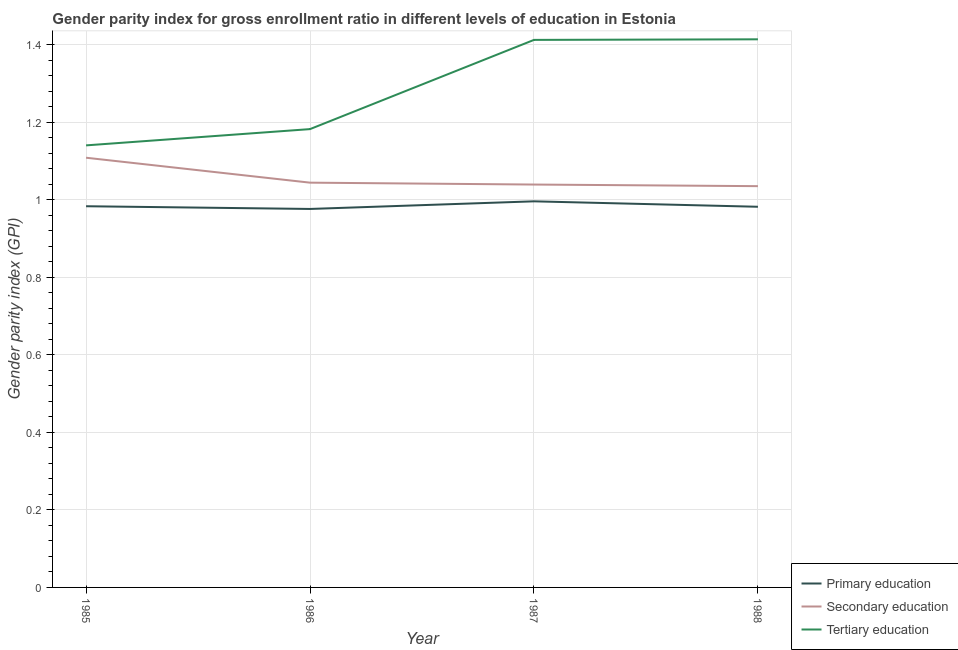What is the gender parity index in secondary education in 1987?
Provide a succinct answer. 1.04. Across all years, what is the maximum gender parity index in tertiary education?
Give a very brief answer. 1.41. Across all years, what is the minimum gender parity index in tertiary education?
Make the answer very short. 1.14. What is the total gender parity index in secondary education in the graph?
Keep it short and to the point. 4.23. What is the difference between the gender parity index in primary education in 1986 and that in 1988?
Your answer should be compact. -0.01. What is the difference between the gender parity index in secondary education in 1985 and the gender parity index in tertiary education in 1988?
Provide a short and direct response. -0.31. What is the average gender parity index in secondary education per year?
Your answer should be compact. 1.06. In the year 1986, what is the difference between the gender parity index in tertiary education and gender parity index in secondary education?
Keep it short and to the point. 0.14. In how many years, is the gender parity index in primary education greater than 0.52?
Your answer should be very brief. 4. What is the ratio of the gender parity index in secondary education in 1985 to that in 1987?
Provide a succinct answer. 1.07. Is the gender parity index in tertiary education in 1986 less than that in 1987?
Ensure brevity in your answer.  Yes. What is the difference between the highest and the second highest gender parity index in tertiary education?
Ensure brevity in your answer.  0. What is the difference between the highest and the lowest gender parity index in tertiary education?
Your answer should be very brief. 0.27. In how many years, is the gender parity index in secondary education greater than the average gender parity index in secondary education taken over all years?
Give a very brief answer. 1. Is it the case that in every year, the sum of the gender parity index in primary education and gender parity index in secondary education is greater than the gender parity index in tertiary education?
Provide a succinct answer. Yes. Is the gender parity index in secondary education strictly greater than the gender parity index in primary education over the years?
Ensure brevity in your answer.  Yes. What is the difference between two consecutive major ticks on the Y-axis?
Keep it short and to the point. 0.2. Are the values on the major ticks of Y-axis written in scientific E-notation?
Offer a terse response. No. What is the title of the graph?
Your answer should be compact. Gender parity index for gross enrollment ratio in different levels of education in Estonia. What is the label or title of the X-axis?
Offer a very short reply. Year. What is the label or title of the Y-axis?
Your answer should be compact. Gender parity index (GPI). What is the Gender parity index (GPI) in Primary education in 1985?
Provide a succinct answer. 0.98. What is the Gender parity index (GPI) of Secondary education in 1985?
Ensure brevity in your answer.  1.11. What is the Gender parity index (GPI) of Tertiary education in 1985?
Give a very brief answer. 1.14. What is the Gender parity index (GPI) in Primary education in 1986?
Give a very brief answer. 0.98. What is the Gender parity index (GPI) of Secondary education in 1986?
Offer a terse response. 1.04. What is the Gender parity index (GPI) of Tertiary education in 1986?
Keep it short and to the point. 1.18. What is the Gender parity index (GPI) in Primary education in 1987?
Give a very brief answer. 1. What is the Gender parity index (GPI) in Secondary education in 1987?
Ensure brevity in your answer.  1.04. What is the Gender parity index (GPI) in Tertiary education in 1987?
Offer a terse response. 1.41. What is the Gender parity index (GPI) of Primary education in 1988?
Provide a short and direct response. 0.98. What is the Gender parity index (GPI) in Secondary education in 1988?
Give a very brief answer. 1.04. What is the Gender parity index (GPI) in Tertiary education in 1988?
Ensure brevity in your answer.  1.41. Across all years, what is the maximum Gender parity index (GPI) in Primary education?
Offer a very short reply. 1. Across all years, what is the maximum Gender parity index (GPI) of Secondary education?
Your response must be concise. 1.11. Across all years, what is the maximum Gender parity index (GPI) in Tertiary education?
Give a very brief answer. 1.41. Across all years, what is the minimum Gender parity index (GPI) of Primary education?
Provide a short and direct response. 0.98. Across all years, what is the minimum Gender parity index (GPI) in Secondary education?
Provide a short and direct response. 1.04. Across all years, what is the minimum Gender parity index (GPI) in Tertiary education?
Keep it short and to the point. 1.14. What is the total Gender parity index (GPI) in Primary education in the graph?
Provide a short and direct response. 3.94. What is the total Gender parity index (GPI) in Secondary education in the graph?
Give a very brief answer. 4.23. What is the total Gender parity index (GPI) of Tertiary education in the graph?
Provide a short and direct response. 5.15. What is the difference between the Gender parity index (GPI) of Primary education in 1985 and that in 1986?
Provide a succinct answer. 0.01. What is the difference between the Gender parity index (GPI) of Secondary education in 1985 and that in 1986?
Make the answer very short. 0.06. What is the difference between the Gender parity index (GPI) of Tertiary education in 1985 and that in 1986?
Ensure brevity in your answer.  -0.04. What is the difference between the Gender parity index (GPI) of Primary education in 1985 and that in 1987?
Ensure brevity in your answer.  -0.01. What is the difference between the Gender parity index (GPI) in Secondary education in 1985 and that in 1987?
Your answer should be very brief. 0.07. What is the difference between the Gender parity index (GPI) in Tertiary education in 1985 and that in 1987?
Offer a terse response. -0.27. What is the difference between the Gender parity index (GPI) of Primary education in 1985 and that in 1988?
Provide a succinct answer. 0. What is the difference between the Gender parity index (GPI) of Secondary education in 1985 and that in 1988?
Offer a terse response. 0.07. What is the difference between the Gender parity index (GPI) in Tertiary education in 1985 and that in 1988?
Your answer should be compact. -0.27. What is the difference between the Gender parity index (GPI) of Primary education in 1986 and that in 1987?
Offer a very short reply. -0.02. What is the difference between the Gender parity index (GPI) in Secondary education in 1986 and that in 1987?
Provide a succinct answer. 0. What is the difference between the Gender parity index (GPI) in Tertiary education in 1986 and that in 1987?
Make the answer very short. -0.23. What is the difference between the Gender parity index (GPI) in Primary education in 1986 and that in 1988?
Keep it short and to the point. -0.01. What is the difference between the Gender parity index (GPI) in Secondary education in 1986 and that in 1988?
Offer a terse response. 0.01. What is the difference between the Gender parity index (GPI) of Tertiary education in 1986 and that in 1988?
Give a very brief answer. -0.23. What is the difference between the Gender parity index (GPI) in Primary education in 1987 and that in 1988?
Provide a succinct answer. 0.01. What is the difference between the Gender parity index (GPI) of Secondary education in 1987 and that in 1988?
Keep it short and to the point. 0. What is the difference between the Gender parity index (GPI) in Tertiary education in 1987 and that in 1988?
Provide a succinct answer. -0. What is the difference between the Gender parity index (GPI) in Primary education in 1985 and the Gender parity index (GPI) in Secondary education in 1986?
Ensure brevity in your answer.  -0.06. What is the difference between the Gender parity index (GPI) of Primary education in 1985 and the Gender parity index (GPI) of Tertiary education in 1986?
Provide a short and direct response. -0.2. What is the difference between the Gender parity index (GPI) in Secondary education in 1985 and the Gender parity index (GPI) in Tertiary education in 1986?
Your answer should be compact. -0.07. What is the difference between the Gender parity index (GPI) of Primary education in 1985 and the Gender parity index (GPI) of Secondary education in 1987?
Keep it short and to the point. -0.06. What is the difference between the Gender parity index (GPI) of Primary education in 1985 and the Gender parity index (GPI) of Tertiary education in 1987?
Ensure brevity in your answer.  -0.43. What is the difference between the Gender parity index (GPI) in Secondary education in 1985 and the Gender parity index (GPI) in Tertiary education in 1987?
Keep it short and to the point. -0.3. What is the difference between the Gender parity index (GPI) in Primary education in 1985 and the Gender parity index (GPI) in Secondary education in 1988?
Give a very brief answer. -0.05. What is the difference between the Gender parity index (GPI) of Primary education in 1985 and the Gender parity index (GPI) of Tertiary education in 1988?
Give a very brief answer. -0.43. What is the difference between the Gender parity index (GPI) in Secondary education in 1985 and the Gender parity index (GPI) in Tertiary education in 1988?
Offer a terse response. -0.31. What is the difference between the Gender parity index (GPI) of Primary education in 1986 and the Gender parity index (GPI) of Secondary education in 1987?
Provide a short and direct response. -0.06. What is the difference between the Gender parity index (GPI) in Primary education in 1986 and the Gender parity index (GPI) in Tertiary education in 1987?
Offer a terse response. -0.44. What is the difference between the Gender parity index (GPI) of Secondary education in 1986 and the Gender parity index (GPI) of Tertiary education in 1987?
Give a very brief answer. -0.37. What is the difference between the Gender parity index (GPI) in Primary education in 1986 and the Gender parity index (GPI) in Secondary education in 1988?
Provide a short and direct response. -0.06. What is the difference between the Gender parity index (GPI) in Primary education in 1986 and the Gender parity index (GPI) in Tertiary education in 1988?
Make the answer very short. -0.44. What is the difference between the Gender parity index (GPI) of Secondary education in 1986 and the Gender parity index (GPI) of Tertiary education in 1988?
Offer a terse response. -0.37. What is the difference between the Gender parity index (GPI) in Primary education in 1987 and the Gender parity index (GPI) in Secondary education in 1988?
Make the answer very short. -0.04. What is the difference between the Gender parity index (GPI) in Primary education in 1987 and the Gender parity index (GPI) in Tertiary education in 1988?
Offer a very short reply. -0.42. What is the difference between the Gender parity index (GPI) in Secondary education in 1987 and the Gender parity index (GPI) in Tertiary education in 1988?
Provide a succinct answer. -0.37. What is the average Gender parity index (GPI) of Primary education per year?
Offer a terse response. 0.98. What is the average Gender parity index (GPI) in Secondary education per year?
Offer a terse response. 1.06. What is the average Gender parity index (GPI) of Tertiary education per year?
Keep it short and to the point. 1.29. In the year 1985, what is the difference between the Gender parity index (GPI) in Primary education and Gender parity index (GPI) in Secondary education?
Your response must be concise. -0.13. In the year 1985, what is the difference between the Gender parity index (GPI) in Primary education and Gender parity index (GPI) in Tertiary education?
Provide a short and direct response. -0.16. In the year 1985, what is the difference between the Gender parity index (GPI) in Secondary education and Gender parity index (GPI) in Tertiary education?
Your response must be concise. -0.03. In the year 1986, what is the difference between the Gender parity index (GPI) of Primary education and Gender parity index (GPI) of Secondary education?
Provide a succinct answer. -0.07. In the year 1986, what is the difference between the Gender parity index (GPI) of Primary education and Gender parity index (GPI) of Tertiary education?
Keep it short and to the point. -0.21. In the year 1986, what is the difference between the Gender parity index (GPI) of Secondary education and Gender parity index (GPI) of Tertiary education?
Provide a short and direct response. -0.14. In the year 1987, what is the difference between the Gender parity index (GPI) of Primary education and Gender parity index (GPI) of Secondary education?
Your answer should be very brief. -0.04. In the year 1987, what is the difference between the Gender parity index (GPI) of Primary education and Gender parity index (GPI) of Tertiary education?
Keep it short and to the point. -0.42. In the year 1987, what is the difference between the Gender parity index (GPI) in Secondary education and Gender parity index (GPI) in Tertiary education?
Offer a very short reply. -0.37. In the year 1988, what is the difference between the Gender parity index (GPI) of Primary education and Gender parity index (GPI) of Secondary education?
Your answer should be compact. -0.05. In the year 1988, what is the difference between the Gender parity index (GPI) in Primary education and Gender parity index (GPI) in Tertiary education?
Offer a very short reply. -0.43. In the year 1988, what is the difference between the Gender parity index (GPI) in Secondary education and Gender parity index (GPI) in Tertiary education?
Ensure brevity in your answer.  -0.38. What is the ratio of the Gender parity index (GPI) in Primary education in 1985 to that in 1986?
Offer a very short reply. 1.01. What is the ratio of the Gender parity index (GPI) of Secondary education in 1985 to that in 1986?
Your answer should be compact. 1.06. What is the ratio of the Gender parity index (GPI) of Tertiary education in 1985 to that in 1986?
Offer a terse response. 0.96. What is the ratio of the Gender parity index (GPI) in Primary education in 1985 to that in 1987?
Provide a succinct answer. 0.99. What is the ratio of the Gender parity index (GPI) in Secondary education in 1985 to that in 1987?
Keep it short and to the point. 1.07. What is the ratio of the Gender parity index (GPI) of Tertiary education in 1985 to that in 1987?
Offer a terse response. 0.81. What is the ratio of the Gender parity index (GPI) of Secondary education in 1985 to that in 1988?
Offer a terse response. 1.07. What is the ratio of the Gender parity index (GPI) in Tertiary education in 1985 to that in 1988?
Your response must be concise. 0.81. What is the ratio of the Gender parity index (GPI) of Primary education in 1986 to that in 1987?
Ensure brevity in your answer.  0.98. What is the ratio of the Gender parity index (GPI) of Tertiary education in 1986 to that in 1987?
Make the answer very short. 0.84. What is the ratio of the Gender parity index (GPI) in Secondary education in 1986 to that in 1988?
Keep it short and to the point. 1.01. What is the ratio of the Gender parity index (GPI) of Tertiary education in 1986 to that in 1988?
Ensure brevity in your answer.  0.84. What is the ratio of the Gender parity index (GPI) of Primary education in 1987 to that in 1988?
Ensure brevity in your answer.  1.01. What is the difference between the highest and the second highest Gender parity index (GPI) in Primary education?
Make the answer very short. 0.01. What is the difference between the highest and the second highest Gender parity index (GPI) of Secondary education?
Offer a very short reply. 0.06. What is the difference between the highest and the second highest Gender parity index (GPI) in Tertiary education?
Make the answer very short. 0. What is the difference between the highest and the lowest Gender parity index (GPI) in Primary education?
Provide a succinct answer. 0.02. What is the difference between the highest and the lowest Gender parity index (GPI) in Secondary education?
Keep it short and to the point. 0.07. What is the difference between the highest and the lowest Gender parity index (GPI) of Tertiary education?
Offer a terse response. 0.27. 